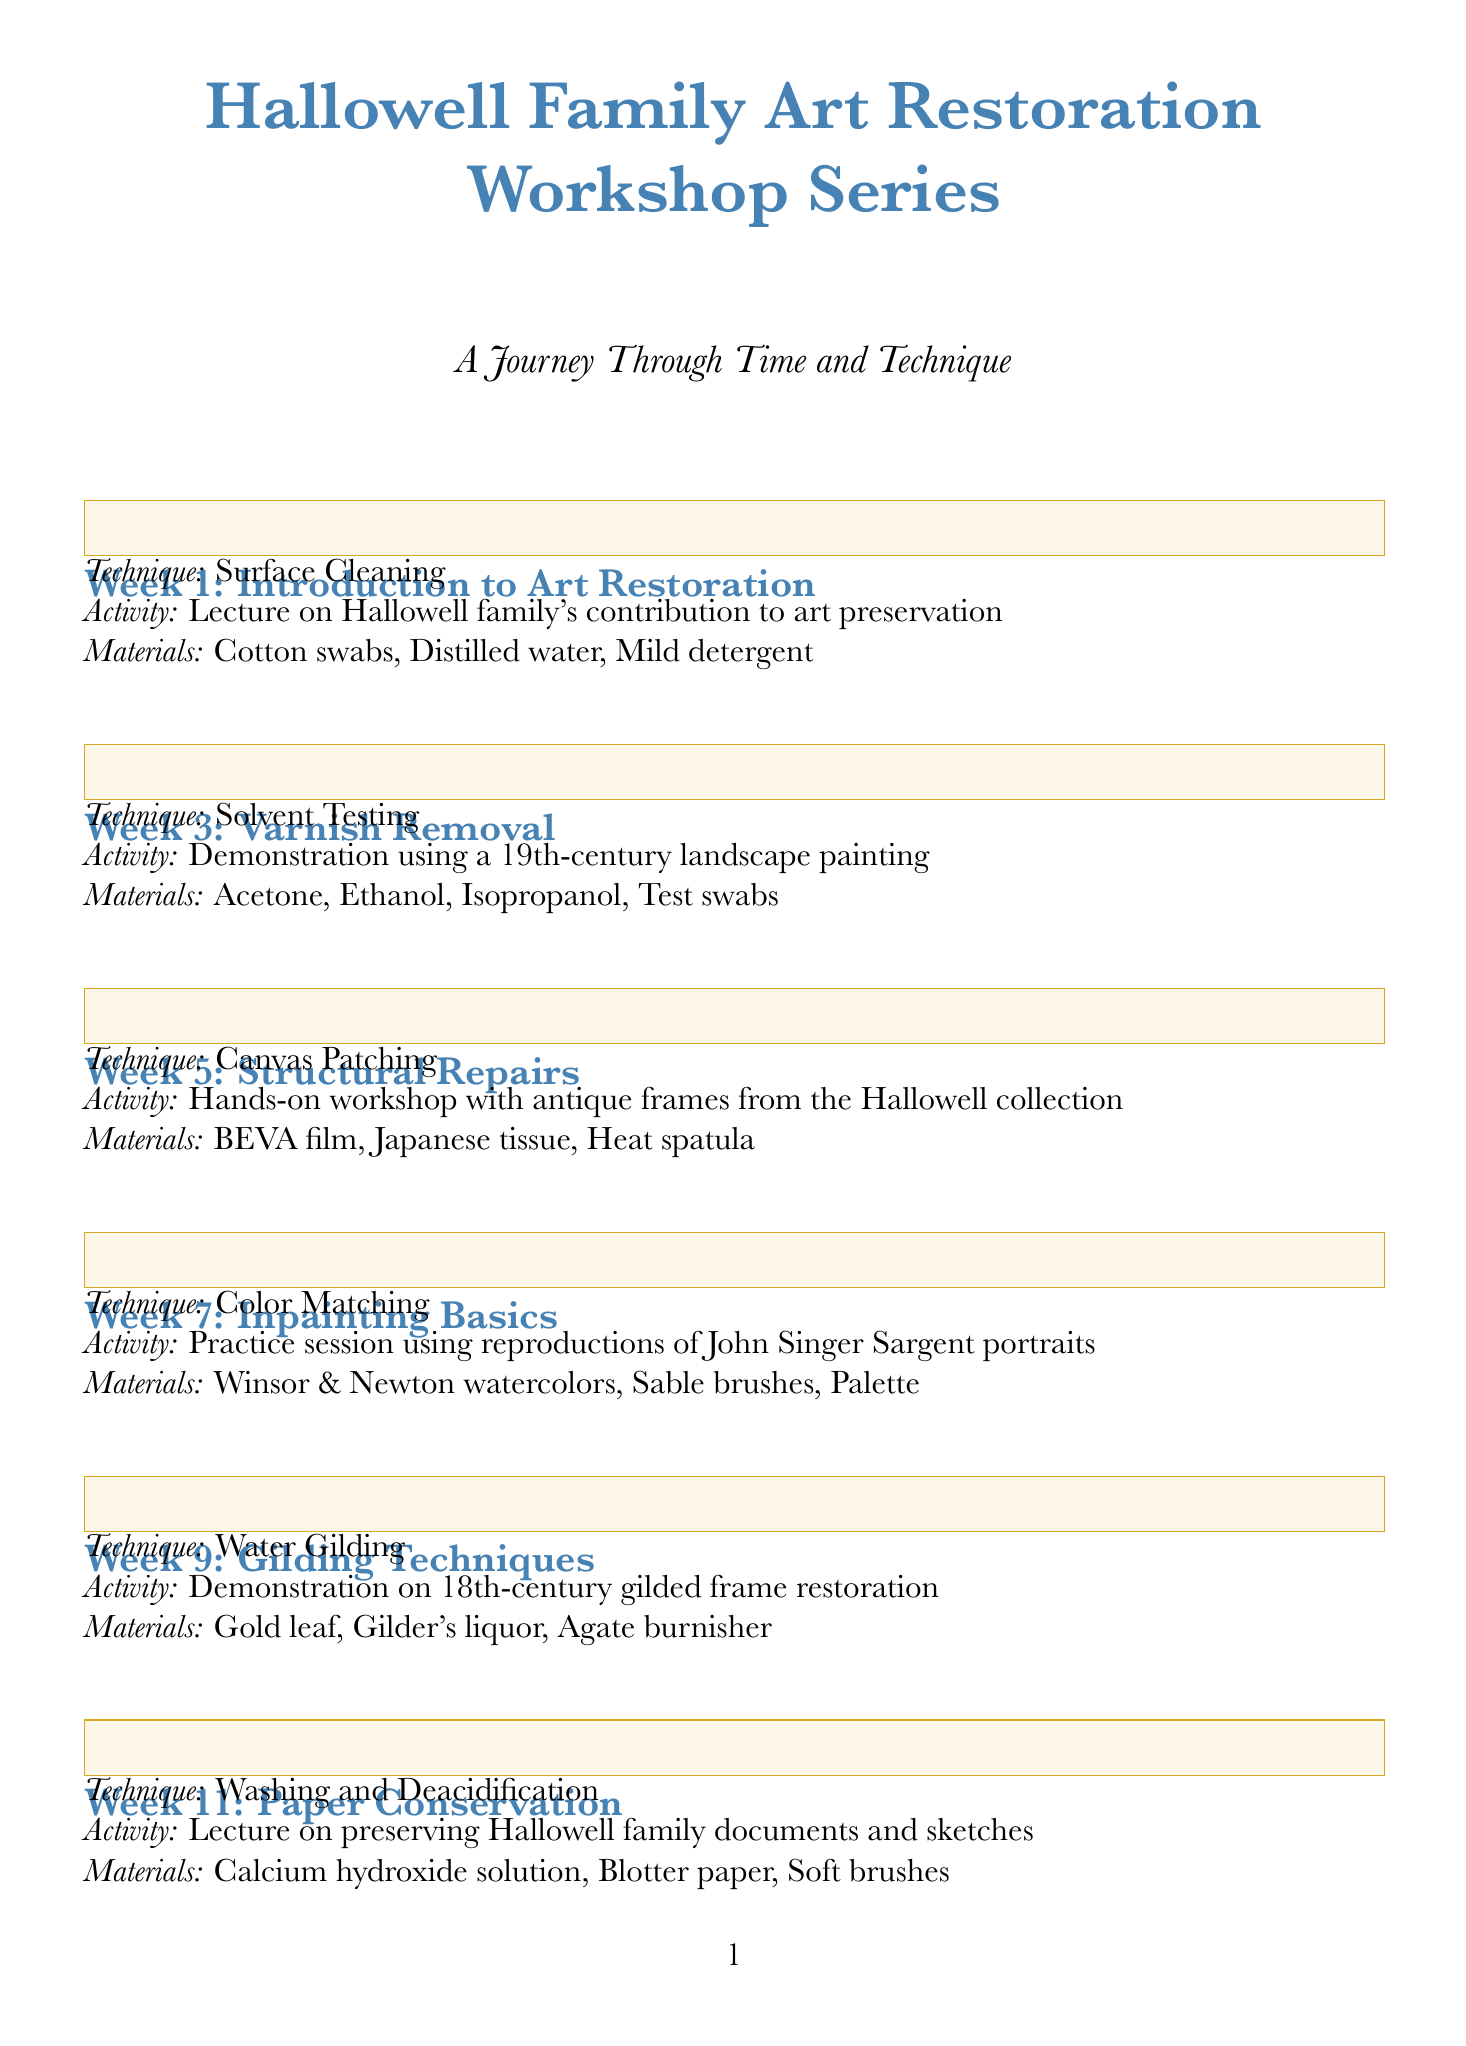What is the topic of Week 1? The topic for Week 1 is specified in the document as "Introduction to Art Restoration."
Answer: Introduction to Art Restoration What technique is taught in Week 5? The document lists the technique for Week 5 as "Canvas Patching."
Answer: Canvas Patching What activity is scheduled for Week 9? The activity for Week 9 is described as a "Demonstration on 18th-century gilded frame restoration."
Answer: Demonstration on 18th-century gilded frame restoration How many workshops are covered in total? There are ten workshops listed in the document, each corresponding to a specific week.
Answer: 10 Which week focuses on preventive conservation? The document indicates that preventive conservation is covered in Week 15.
Answer: Week 15 What is the main focus of the final project? The final project culminates in a "Restore a painting from the Hallowell family collection."
Answer: Restore a painting from the Hallowell family collection In which week do participants first learn about inpainting? The first session on inpainting is scheduled for Week 7.
Answer: Week 7 What materials are used in the Varnish Removal workshop? The materials for the Varnish Removal workshop include "Acetone, Ethanol, Isopropanol, Test swabs."
Answer: Acetone, Ethanol, Isopropanol, Test swabs What color is used for the workshop title in the document? The document specifies that the color used for the workshop title is a shade called "hallowellblue."
Answer: hallowellblue 